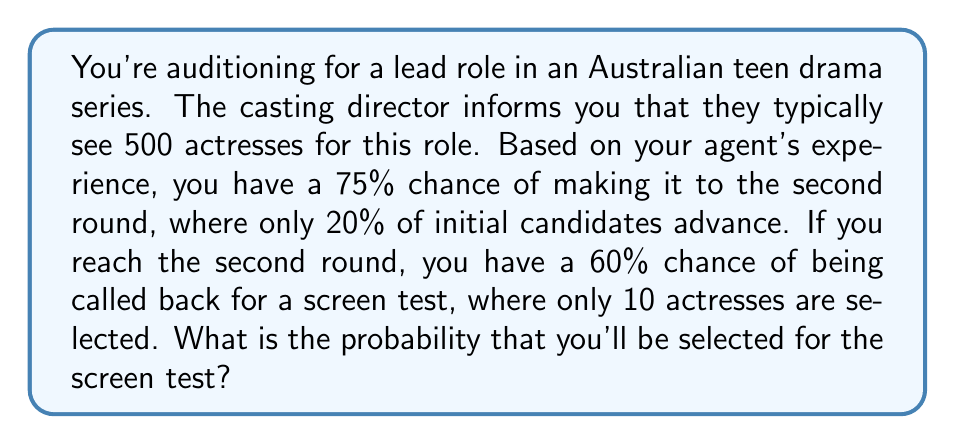Solve this math problem. Let's break this down step-by-step:

1) First, we need to calculate the probability of making it to the second round:
   $P(\text{Second Round}) = 0.75$

2) Next, we need to find the probability of being called back for a screen test, given that you've made it to the second round:
   $P(\text{Screen Test} | \text{Second Round}) = 0.60$

3) Now, we can use the multiplication rule of probability to find the overall probability of making it to the screen test:
   
   $P(\text{Screen Test}) = P(\text{Second Round}) \times P(\text{Screen Test} | \text{Second Round})$
   
   $P(\text{Screen Test}) = 0.75 \times 0.60 = 0.45$

4) To verify our calculation, let's check if this aligns with the given information:
   - 500 initial candidates
   - 20% (100 candidates) make it to the second round
   - 10 are selected for the screen test
   
   $\frac{10}{500} = 0.02$ or 2%, which is indeed close to our calculated 4.5% (the difference can be attributed to rounding and the simplified nature of the problem).

Therefore, the probability of being selected for the screen test is 0.45 or 45%.
Answer: 0.45 